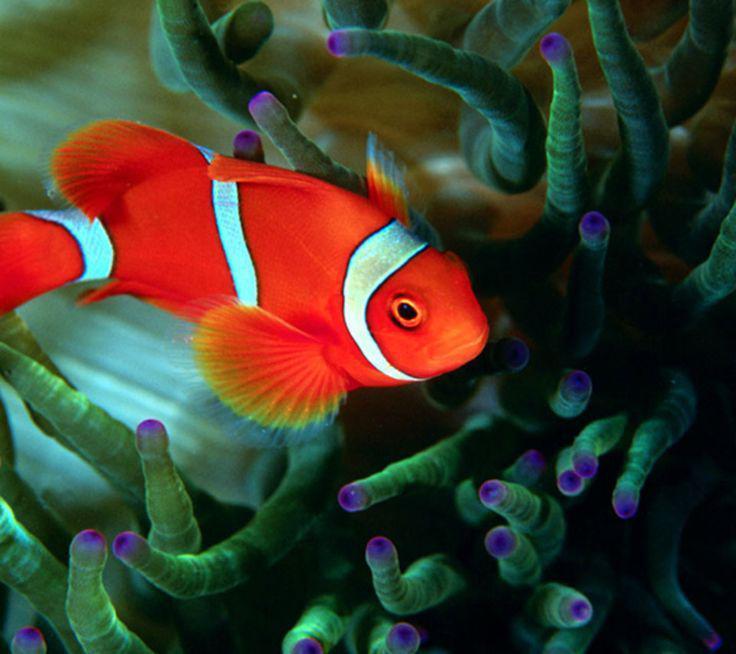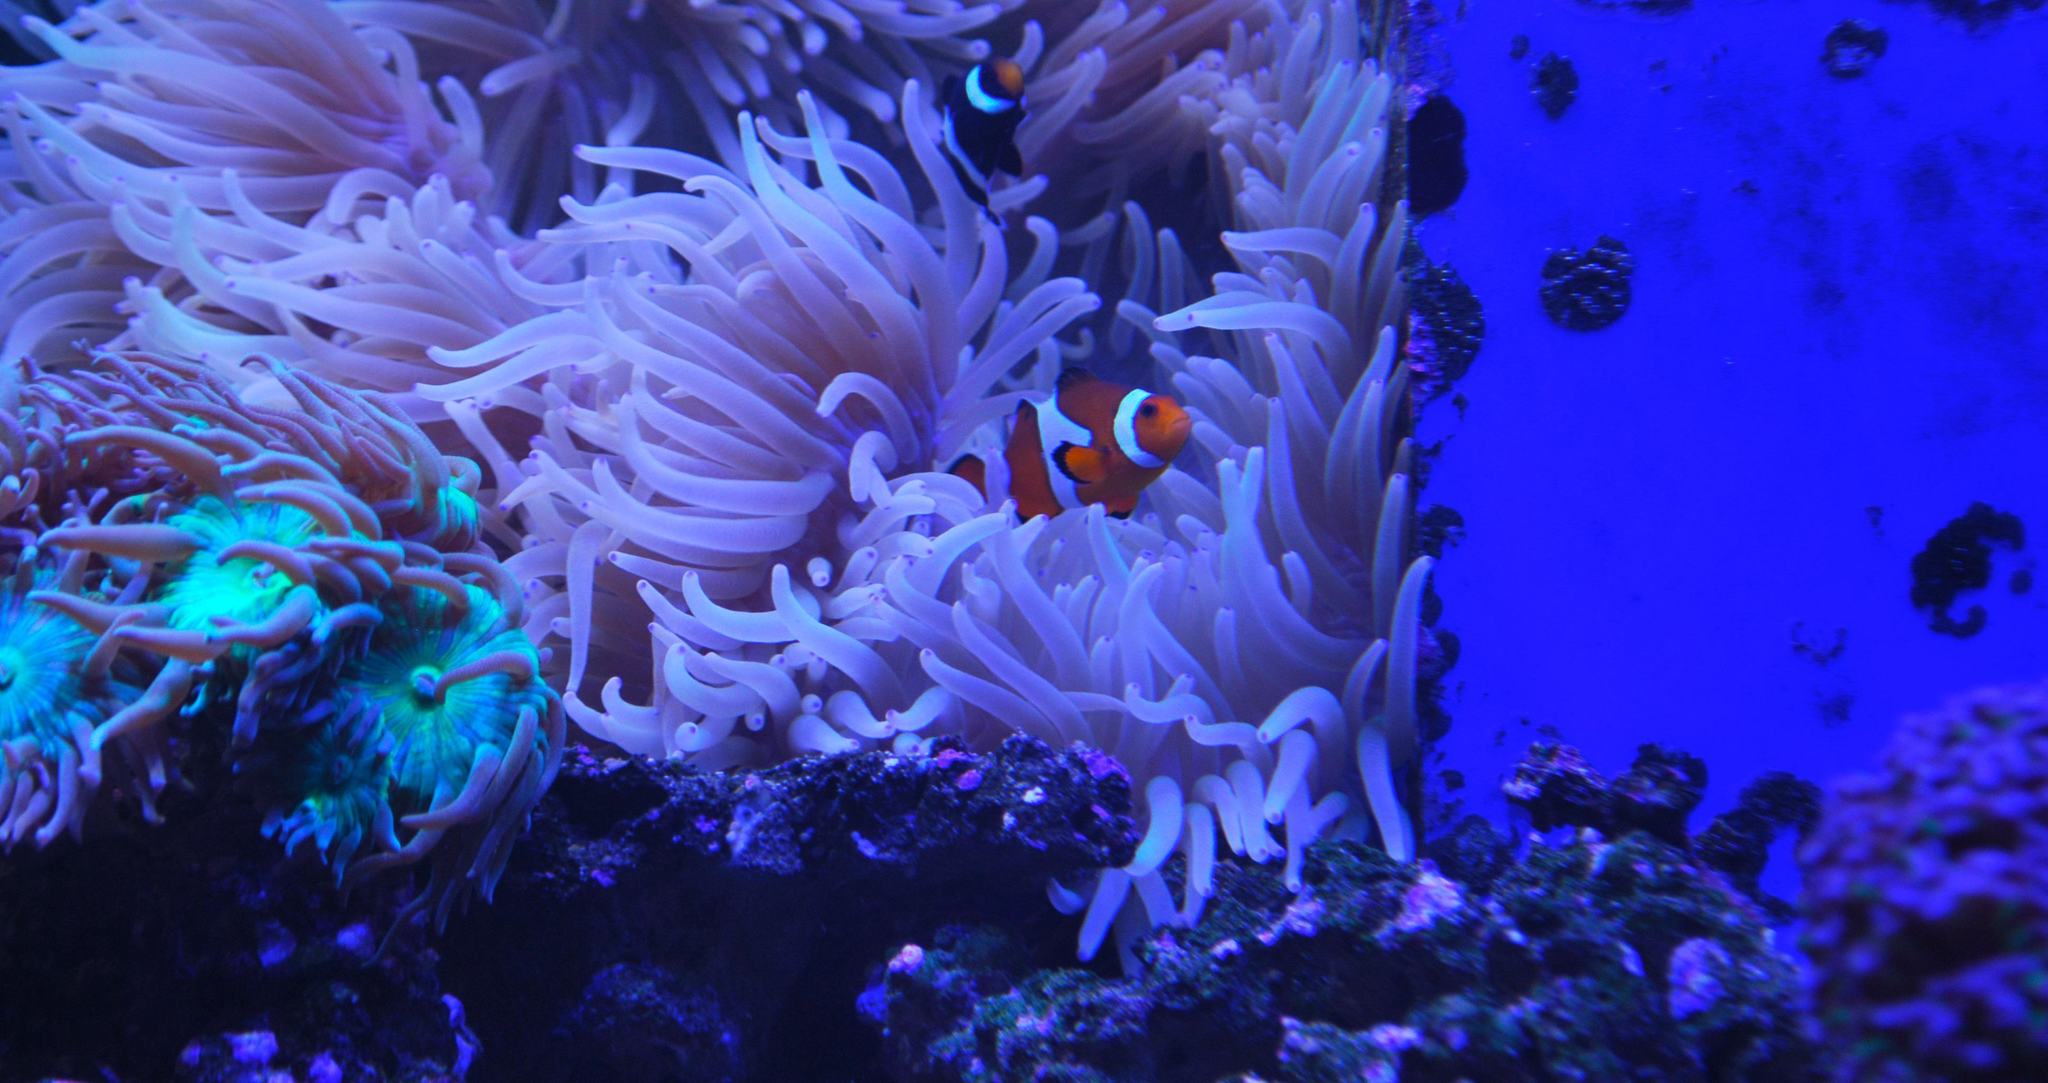The first image is the image on the left, the second image is the image on the right. For the images displayed, is the sentence "there is one clownfish facing right on the right image" factually correct? Answer yes or no. Yes. 